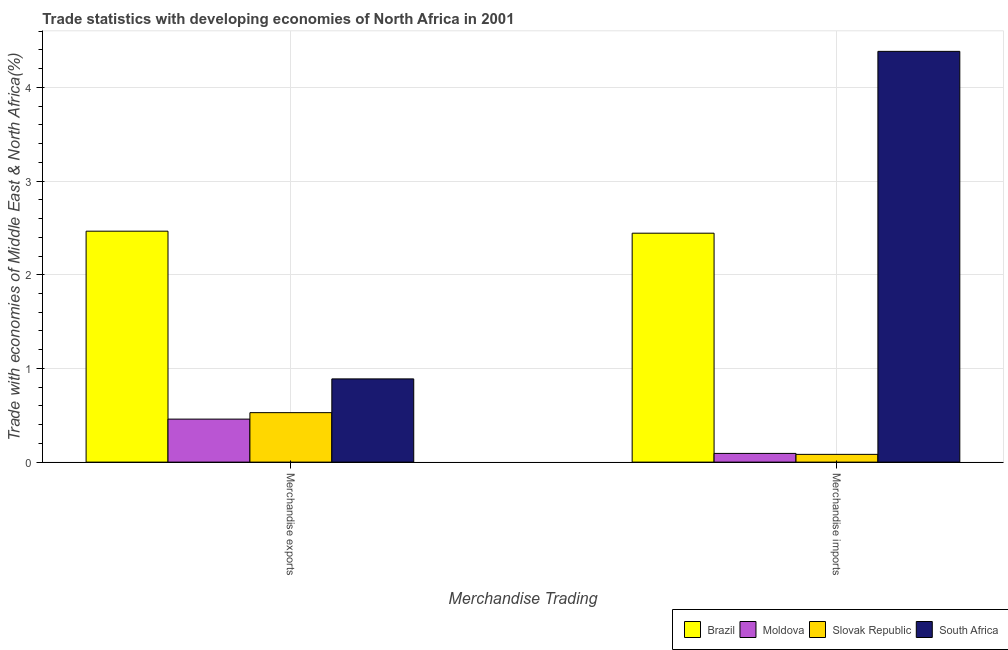How many different coloured bars are there?
Your answer should be compact. 4. Are the number of bars per tick equal to the number of legend labels?
Provide a succinct answer. Yes. Are the number of bars on each tick of the X-axis equal?
Your response must be concise. Yes. What is the label of the 2nd group of bars from the left?
Your response must be concise. Merchandise imports. What is the merchandise imports in South Africa?
Provide a short and direct response. 4.38. Across all countries, what is the maximum merchandise exports?
Make the answer very short. 2.47. Across all countries, what is the minimum merchandise exports?
Ensure brevity in your answer.  0.46. In which country was the merchandise exports minimum?
Your response must be concise. Moldova. What is the total merchandise exports in the graph?
Keep it short and to the point. 4.34. What is the difference between the merchandise exports in Slovak Republic and that in Brazil?
Provide a succinct answer. -1.94. What is the difference between the merchandise exports in South Africa and the merchandise imports in Brazil?
Your answer should be very brief. -1.56. What is the average merchandise exports per country?
Provide a short and direct response. 1.09. What is the difference between the merchandise exports and merchandise imports in Moldova?
Offer a very short reply. 0.37. In how many countries, is the merchandise exports greater than 2.6 %?
Make the answer very short. 0. What is the ratio of the merchandise imports in South Africa to that in Brazil?
Your response must be concise. 1.79. What does the 2nd bar from the left in Merchandise imports represents?
Provide a short and direct response. Moldova. How many bars are there?
Give a very brief answer. 8. Are the values on the major ticks of Y-axis written in scientific E-notation?
Offer a terse response. No. Does the graph contain any zero values?
Provide a short and direct response. No. Does the graph contain grids?
Provide a succinct answer. Yes. Where does the legend appear in the graph?
Keep it short and to the point. Bottom right. How many legend labels are there?
Make the answer very short. 4. How are the legend labels stacked?
Ensure brevity in your answer.  Horizontal. What is the title of the graph?
Your response must be concise. Trade statistics with developing economies of North Africa in 2001. Does "East Asia (developing only)" appear as one of the legend labels in the graph?
Your answer should be compact. No. What is the label or title of the X-axis?
Provide a short and direct response. Merchandise Trading. What is the label or title of the Y-axis?
Your answer should be very brief. Trade with economies of Middle East & North Africa(%). What is the Trade with economies of Middle East & North Africa(%) of Brazil in Merchandise exports?
Make the answer very short. 2.47. What is the Trade with economies of Middle East & North Africa(%) in Moldova in Merchandise exports?
Offer a terse response. 0.46. What is the Trade with economies of Middle East & North Africa(%) in Slovak Republic in Merchandise exports?
Keep it short and to the point. 0.53. What is the Trade with economies of Middle East & North Africa(%) of South Africa in Merchandise exports?
Make the answer very short. 0.89. What is the Trade with economies of Middle East & North Africa(%) of Brazil in Merchandise imports?
Keep it short and to the point. 2.44. What is the Trade with economies of Middle East & North Africa(%) in Moldova in Merchandise imports?
Give a very brief answer. 0.09. What is the Trade with economies of Middle East & North Africa(%) of Slovak Republic in Merchandise imports?
Offer a very short reply. 0.08. What is the Trade with economies of Middle East & North Africa(%) of South Africa in Merchandise imports?
Your answer should be compact. 4.38. Across all Merchandise Trading, what is the maximum Trade with economies of Middle East & North Africa(%) in Brazil?
Your answer should be compact. 2.47. Across all Merchandise Trading, what is the maximum Trade with economies of Middle East & North Africa(%) of Moldova?
Offer a terse response. 0.46. Across all Merchandise Trading, what is the maximum Trade with economies of Middle East & North Africa(%) in Slovak Republic?
Keep it short and to the point. 0.53. Across all Merchandise Trading, what is the maximum Trade with economies of Middle East & North Africa(%) in South Africa?
Offer a very short reply. 4.38. Across all Merchandise Trading, what is the minimum Trade with economies of Middle East & North Africa(%) in Brazil?
Your answer should be very brief. 2.44. Across all Merchandise Trading, what is the minimum Trade with economies of Middle East & North Africa(%) in Moldova?
Offer a terse response. 0.09. Across all Merchandise Trading, what is the minimum Trade with economies of Middle East & North Africa(%) of Slovak Republic?
Your answer should be very brief. 0.08. Across all Merchandise Trading, what is the minimum Trade with economies of Middle East & North Africa(%) of South Africa?
Provide a short and direct response. 0.89. What is the total Trade with economies of Middle East & North Africa(%) in Brazil in the graph?
Your answer should be compact. 4.91. What is the total Trade with economies of Middle East & North Africa(%) in Moldova in the graph?
Make the answer very short. 0.55. What is the total Trade with economies of Middle East & North Africa(%) of Slovak Republic in the graph?
Provide a short and direct response. 0.61. What is the total Trade with economies of Middle East & North Africa(%) of South Africa in the graph?
Give a very brief answer. 5.27. What is the difference between the Trade with economies of Middle East & North Africa(%) in Brazil in Merchandise exports and that in Merchandise imports?
Ensure brevity in your answer.  0.02. What is the difference between the Trade with economies of Middle East & North Africa(%) of Moldova in Merchandise exports and that in Merchandise imports?
Keep it short and to the point. 0.37. What is the difference between the Trade with economies of Middle East & North Africa(%) of Slovak Republic in Merchandise exports and that in Merchandise imports?
Give a very brief answer. 0.45. What is the difference between the Trade with economies of Middle East & North Africa(%) of South Africa in Merchandise exports and that in Merchandise imports?
Give a very brief answer. -3.5. What is the difference between the Trade with economies of Middle East & North Africa(%) of Brazil in Merchandise exports and the Trade with economies of Middle East & North Africa(%) of Moldova in Merchandise imports?
Your response must be concise. 2.37. What is the difference between the Trade with economies of Middle East & North Africa(%) in Brazil in Merchandise exports and the Trade with economies of Middle East & North Africa(%) in Slovak Republic in Merchandise imports?
Ensure brevity in your answer.  2.38. What is the difference between the Trade with economies of Middle East & North Africa(%) in Brazil in Merchandise exports and the Trade with economies of Middle East & North Africa(%) in South Africa in Merchandise imports?
Provide a short and direct response. -1.92. What is the difference between the Trade with economies of Middle East & North Africa(%) in Moldova in Merchandise exports and the Trade with economies of Middle East & North Africa(%) in Slovak Republic in Merchandise imports?
Offer a very short reply. 0.38. What is the difference between the Trade with economies of Middle East & North Africa(%) in Moldova in Merchandise exports and the Trade with economies of Middle East & North Africa(%) in South Africa in Merchandise imports?
Offer a terse response. -3.93. What is the difference between the Trade with economies of Middle East & North Africa(%) in Slovak Republic in Merchandise exports and the Trade with economies of Middle East & North Africa(%) in South Africa in Merchandise imports?
Make the answer very short. -3.86. What is the average Trade with economies of Middle East & North Africa(%) of Brazil per Merchandise Trading?
Your answer should be very brief. 2.45. What is the average Trade with economies of Middle East & North Africa(%) in Moldova per Merchandise Trading?
Provide a short and direct response. 0.28. What is the average Trade with economies of Middle East & North Africa(%) in Slovak Republic per Merchandise Trading?
Keep it short and to the point. 0.31. What is the average Trade with economies of Middle East & North Africa(%) in South Africa per Merchandise Trading?
Your answer should be compact. 2.64. What is the difference between the Trade with economies of Middle East & North Africa(%) in Brazil and Trade with economies of Middle East & North Africa(%) in Moldova in Merchandise exports?
Offer a terse response. 2.01. What is the difference between the Trade with economies of Middle East & North Africa(%) of Brazil and Trade with economies of Middle East & North Africa(%) of Slovak Republic in Merchandise exports?
Ensure brevity in your answer.  1.94. What is the difference between the Trade with economies of Middle East & North Africa(%) of Brazil and Trade with economies of Middle East & North Africa(%) of South Africa in Merchandise exports?
Ensure brevity in your answer.  1.58. What is the difference between the Trade with economies of Middle East & North Africa(%) in Moldova and Trade with economies of Middle East & North Africa(%) in Slovak Republic in Merchandise exports?
Make the answer very short. -0.07. What is the difference between the Trade with economies of Middle East & North Africa(%) of Moldova and Trade with economies of Middle East & North Africa(%) of South Africa in Merchandise exports?
Offer a very short reply. -0.43. What is the difference between the Trade with economies of Middle East & North Africa(%) in Slovak Republic and Trade with economies of Middle East & North Africa(%) in South Africa in Merchandise exports?
Make the answer very short. -0.36. What is the difference between the Trade with economies of Middle East & North Africa(%) of Brazil and Trade with economies of Middle East & North Africa(%) of Moldova in Merchandise imports?
Keep it short and to the point. 2.35. What is the difference between the Trade with economies of Middle East & North Africa(%) in Brazil and Trade with economies of Middle East & North Africa(%) in Slovak Republic in Merchandise imports?
Provide a short and direct response. 2.36. What is the difference between the Trade with economies of Middle East & North Africa(%) in Brazil and Trade with economies of Middle East & North Africa(%) in South Africa in Merchandise imports?
Make the answer very short. -1.94. What is the difference between the Trade with economies of Middle East & North Africa(%) in Moldova and Trade with economies of Middle East & North Africa(%) in Slovak Republic in Merchandise imports?
Your answer should be very brief. 0.01. What is the difference between the Trade with economies of Middle East & North Africa(%) of Moldova and Trade with economies of Middle East & North Africa(%) of South Africa in Merchandise imports?
Make the answer very short. -4.29. What is the difference between the Trade with economies of Middle East & North Africa(%) in Slovak Republic and Trade with economies of Middle East & North Africa(%) in South Africa in Merchandise imports?
Offer a terse response. -4.3. What is the ratio of the Trade with economies of Middle East & North Africa(%) of Brazil in Merchandise exports to that in Merchandise imports?
Your response must be concise. 1.01. What is the ratio of the Trade with economies of Middle East & North Africa(%) of Moldova in Merchandise exports to that in Merchandise imports?
Provide a succinct answer. 4.94. What is the ratio of the Trade with economies of Middle East & North Africa(%) of Slovak Republic in Merchandise exports to that in Merchandise imports?
Provide a short and direct response. 6.38. What is the ratio of the Trade with economies of Middle East & North Africa(%) of South Africa in Merchandise exports to that in Merchandise imports?
Keep it short and to the point. 0.2. What is the difference between the highest and the second highest Trade with economies of Middle East & North Africa(%) in Brazil?
Your answer should be very brief. 0.02. What is the difference between the highest and the second highest Trade with economies of Middle East & North Africa(%) of Moldova?
Make the answer very short. 0.37. What is the difference between the highest and the second highest Trade with economies of Middle East & North Africa(%) in Slovak Republic?
Offer a terse response. 0.45. What is the difference between the highest and the second highest Trade with economies of Middle East & North Africa(%) in South Africa?
Your response must be concise. 3.5. What is the difference between the highest and the lowest Trade with economies of Middle East & North Africa(%) in Brazil?
Provide a succinct answer. 0.02. What is the difference between the highest and the lowest Trade with economies of Middle East & North Africa(%) in Moldova?
Your answer should be compact. 0.37. What is the difference between the highest and the lowest Trade with economies of Middle East & North Africa(%) in Slovak Republic?
Make the answer very short. 0.45. What is the difference between the highest and the lowest Trade with economies of Middle East & North Africa(%) of South Africa?
Keep it short and to the point. 3.5. 